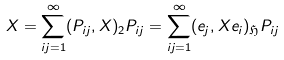Convert formula to latex. <formula><loc_0><loc_0><loc_500><loc_500>X = \sum _ { i j = 1 } ^ { \infty } ( P _ { i j } , X ) _ { 2 } P _ { i j } = \sum _ { i j = 1 } ^ { \infty } ( e _ { j } , X e _ { i } ) _ { \mathfrak { H } } P _ { i j }</formula> 